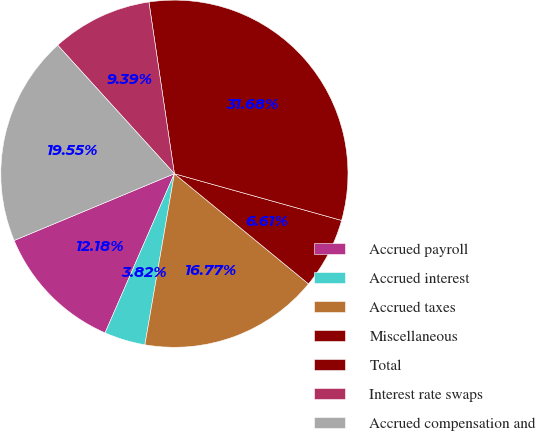<chart> <loc_0><loc_0><loc_500><loc_500><pie_chart><fcel>Accrued payroll<fcel>Accrued interest<fcel>Accrued taxes<fcel>Miscellaneous<fcel>Total<fcel>Interest rate swaps<fcel>Accrued compensation and<nl><fcel>12.18%<fcel>3.82%<fcel>16.77%<fcel>6.61%<fcel>31.68%<fcel>9.39%<fcel>19.55%<nl></chart> 